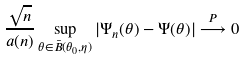<formula> <loc_0><loc_0><loc_500><loc_500>\frac { \sqrt { n } } { a ( n ) } \sup _ { \theta \in \bar { B } ( \theta _ { 0 } , \eta ) } | \Psi _ { n } ( \theta ) - \Psi ( \theta ) | \stackrel { P } { \longrightarrow } 0</formula> 